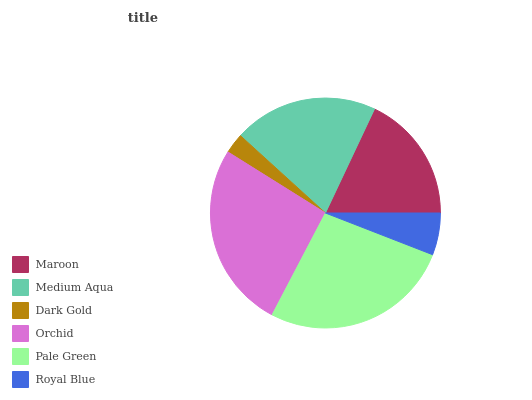Is Dark Gold the minimum?
Answer yes or no. Yes. Is Pale Green the maximum?
Answer yes or no. Yes. Is Medium Aqua the minimum?
Answer yes or no. No. Is Medium Aqua the maximum?
Answer yes or no. No. Is Medium Aqua greater than Maroon?
Answer yes or no. Yes. Is Maroon less than Medium Aqua?
Answer yes or no. Yes. Is Maroon greater than Medium Aqua?
Answer yes or no. No. Is Medium Aqua less than Maroon?
Answer yes or no. No. Is Medium Aqua the high median?
Answer yes or no. Yes. Is Maroon the low median?
Answer yes or no. Yes. Is Maroon the high median?
Answer yes or no. No. Is Medium Aqua the low median?
Answer yes or no. No. 